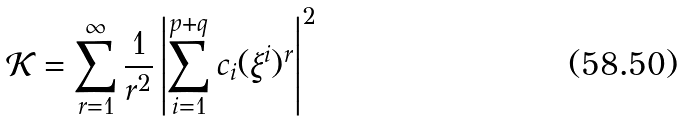Convert formula to latex. <formula><loc_0><loc_0><loc_500><loc_500>\mathcal { K } = \sum _ { r = 1 } ^ { \infty } \frac { 1 } { r ^ { 2 } } \left | \sum _ { i = 1 } ^ { p + q } c _ { i } ( \xi ^ { i } ) ^ { r } \right | ^ { 2 }</formula> 